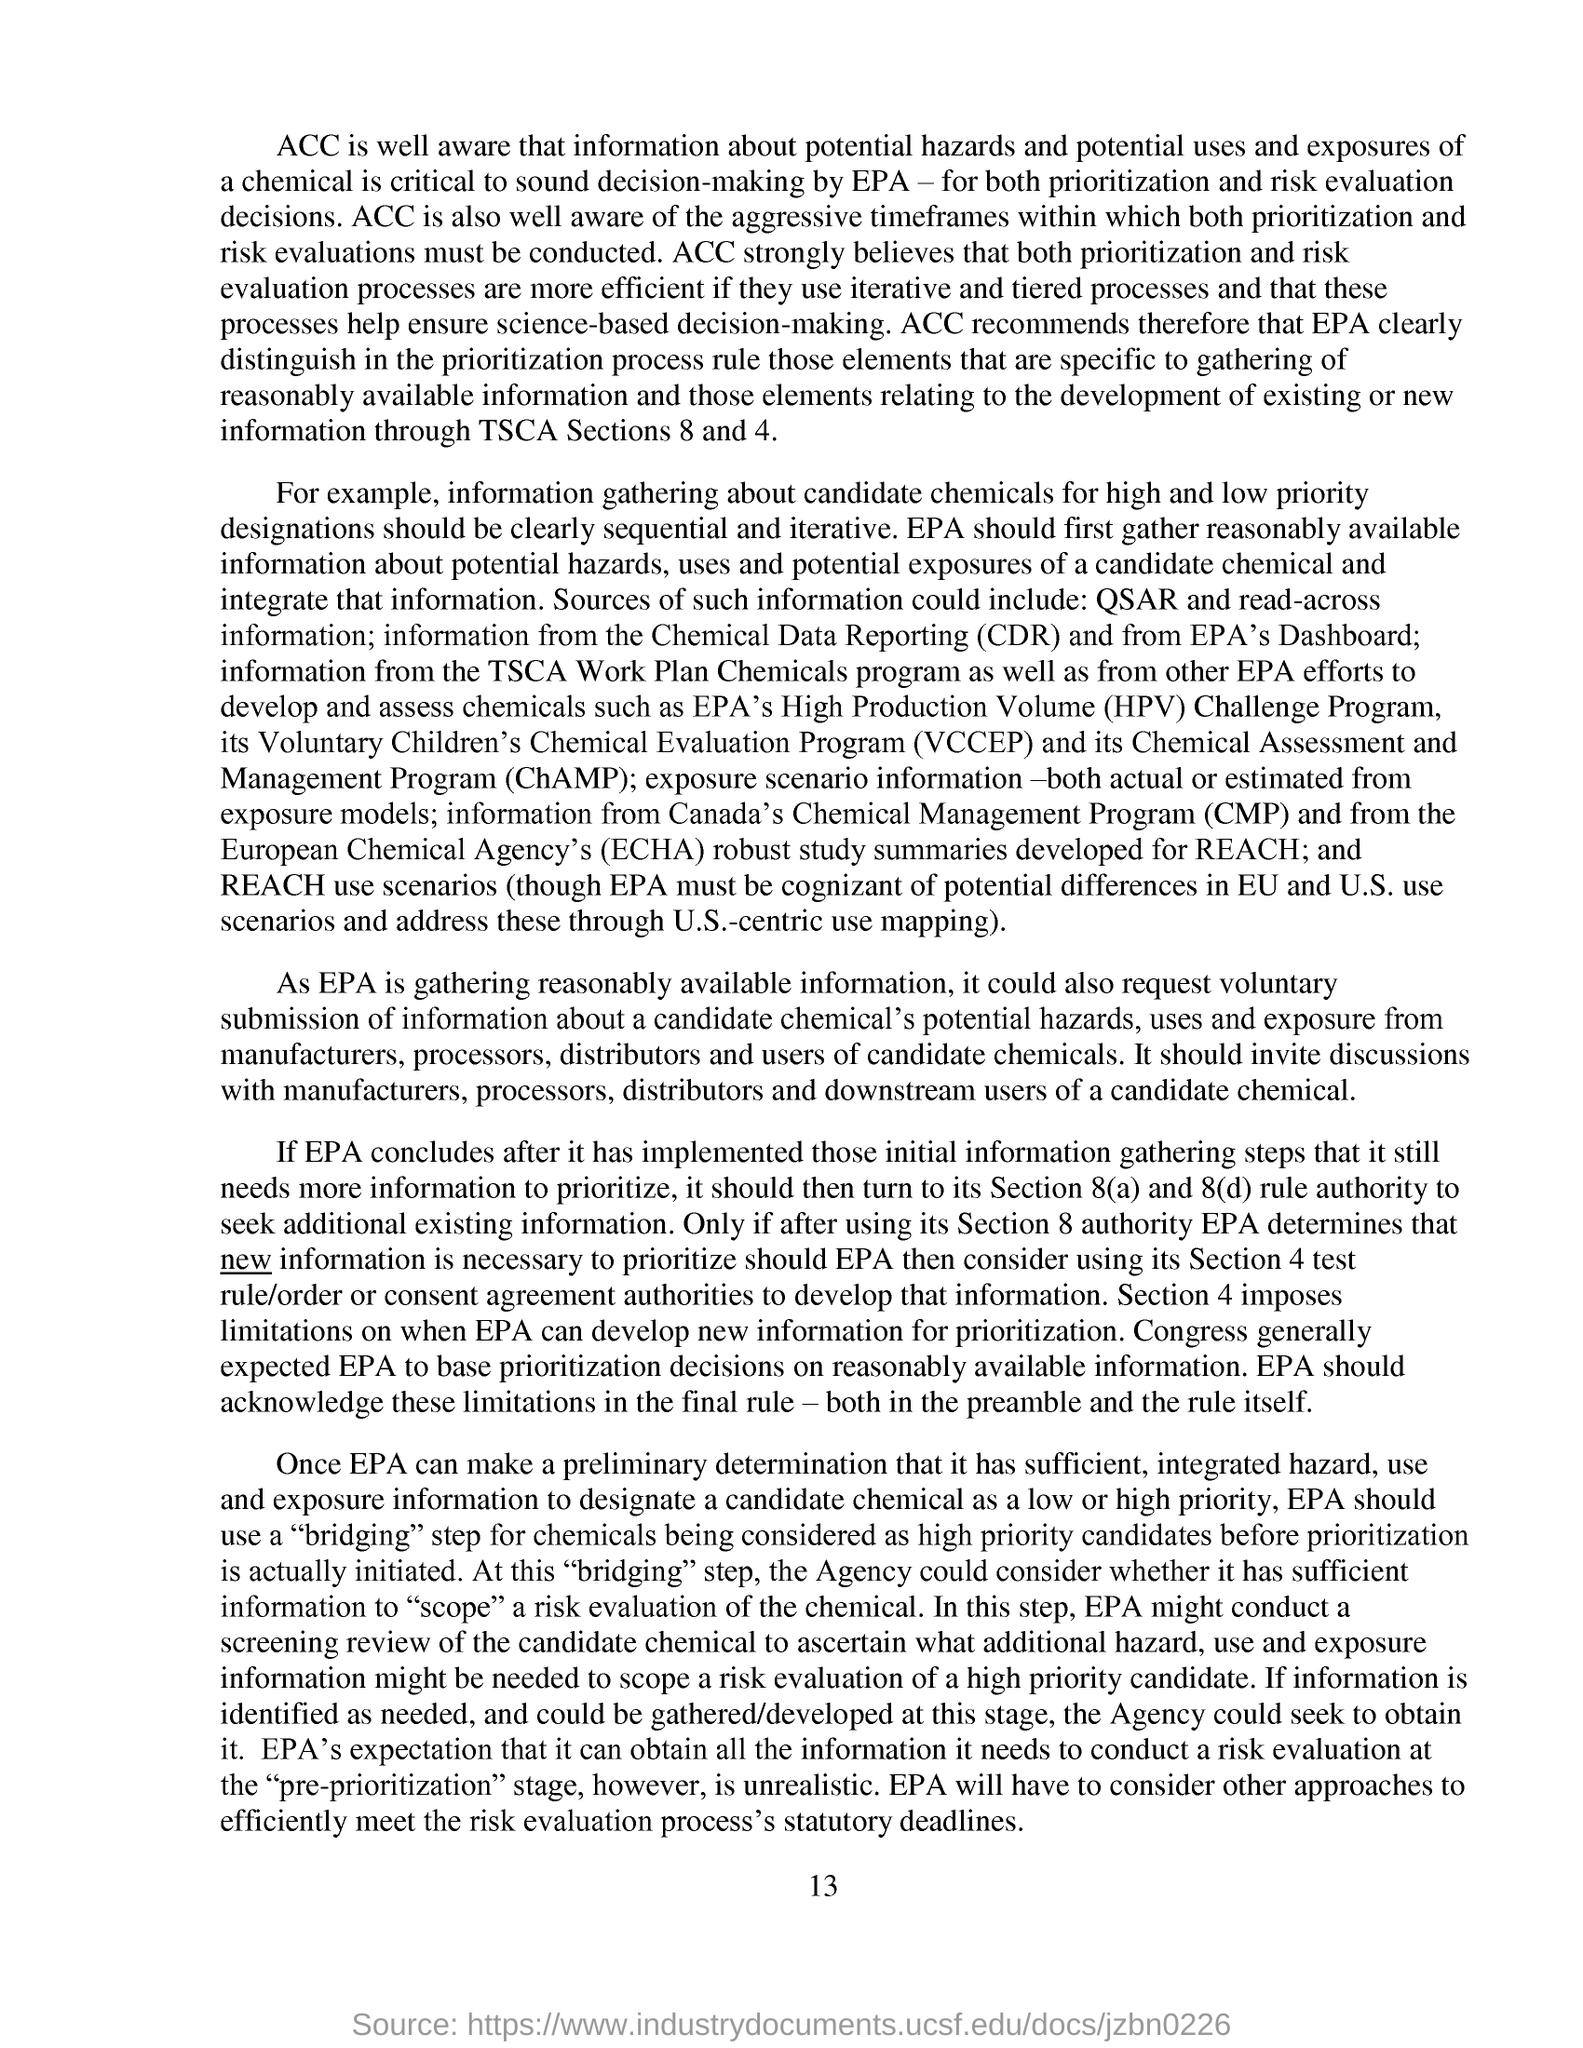What is the fullform of ChAMP?
Your response must be concise. Chemical Assessment and Management Program. What is the abbreviation for Chemical Data Reporting?
Provide a short and direct response. CDR. What is the page no mentioned in this document?
Your answer should be compact. 13. 